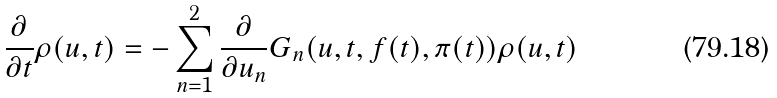<formula> <loc_0><loc_0><loc_500><loc_500>\frac { \partial } { \partial t } \rho ( u , t ) = - \sum _ { n = 1 } ^ { 2 } \frac { \partial } { \partial u _ { n } } G _ { n } ( u , t , f ( t ) , \pi ( t ) ) \rho ( u , t )</formula> 